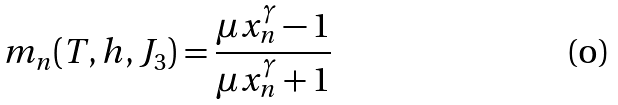<formula> <loc_0><loc_0><loc_500><loc_500>m _ { n } ( T , h , J _ { 3 } ) = \frac { \mu x _ { n } ^ { \gamma } - 1 } { \mu x _ { n } ^ { \gamma } + 1 }</formula> 